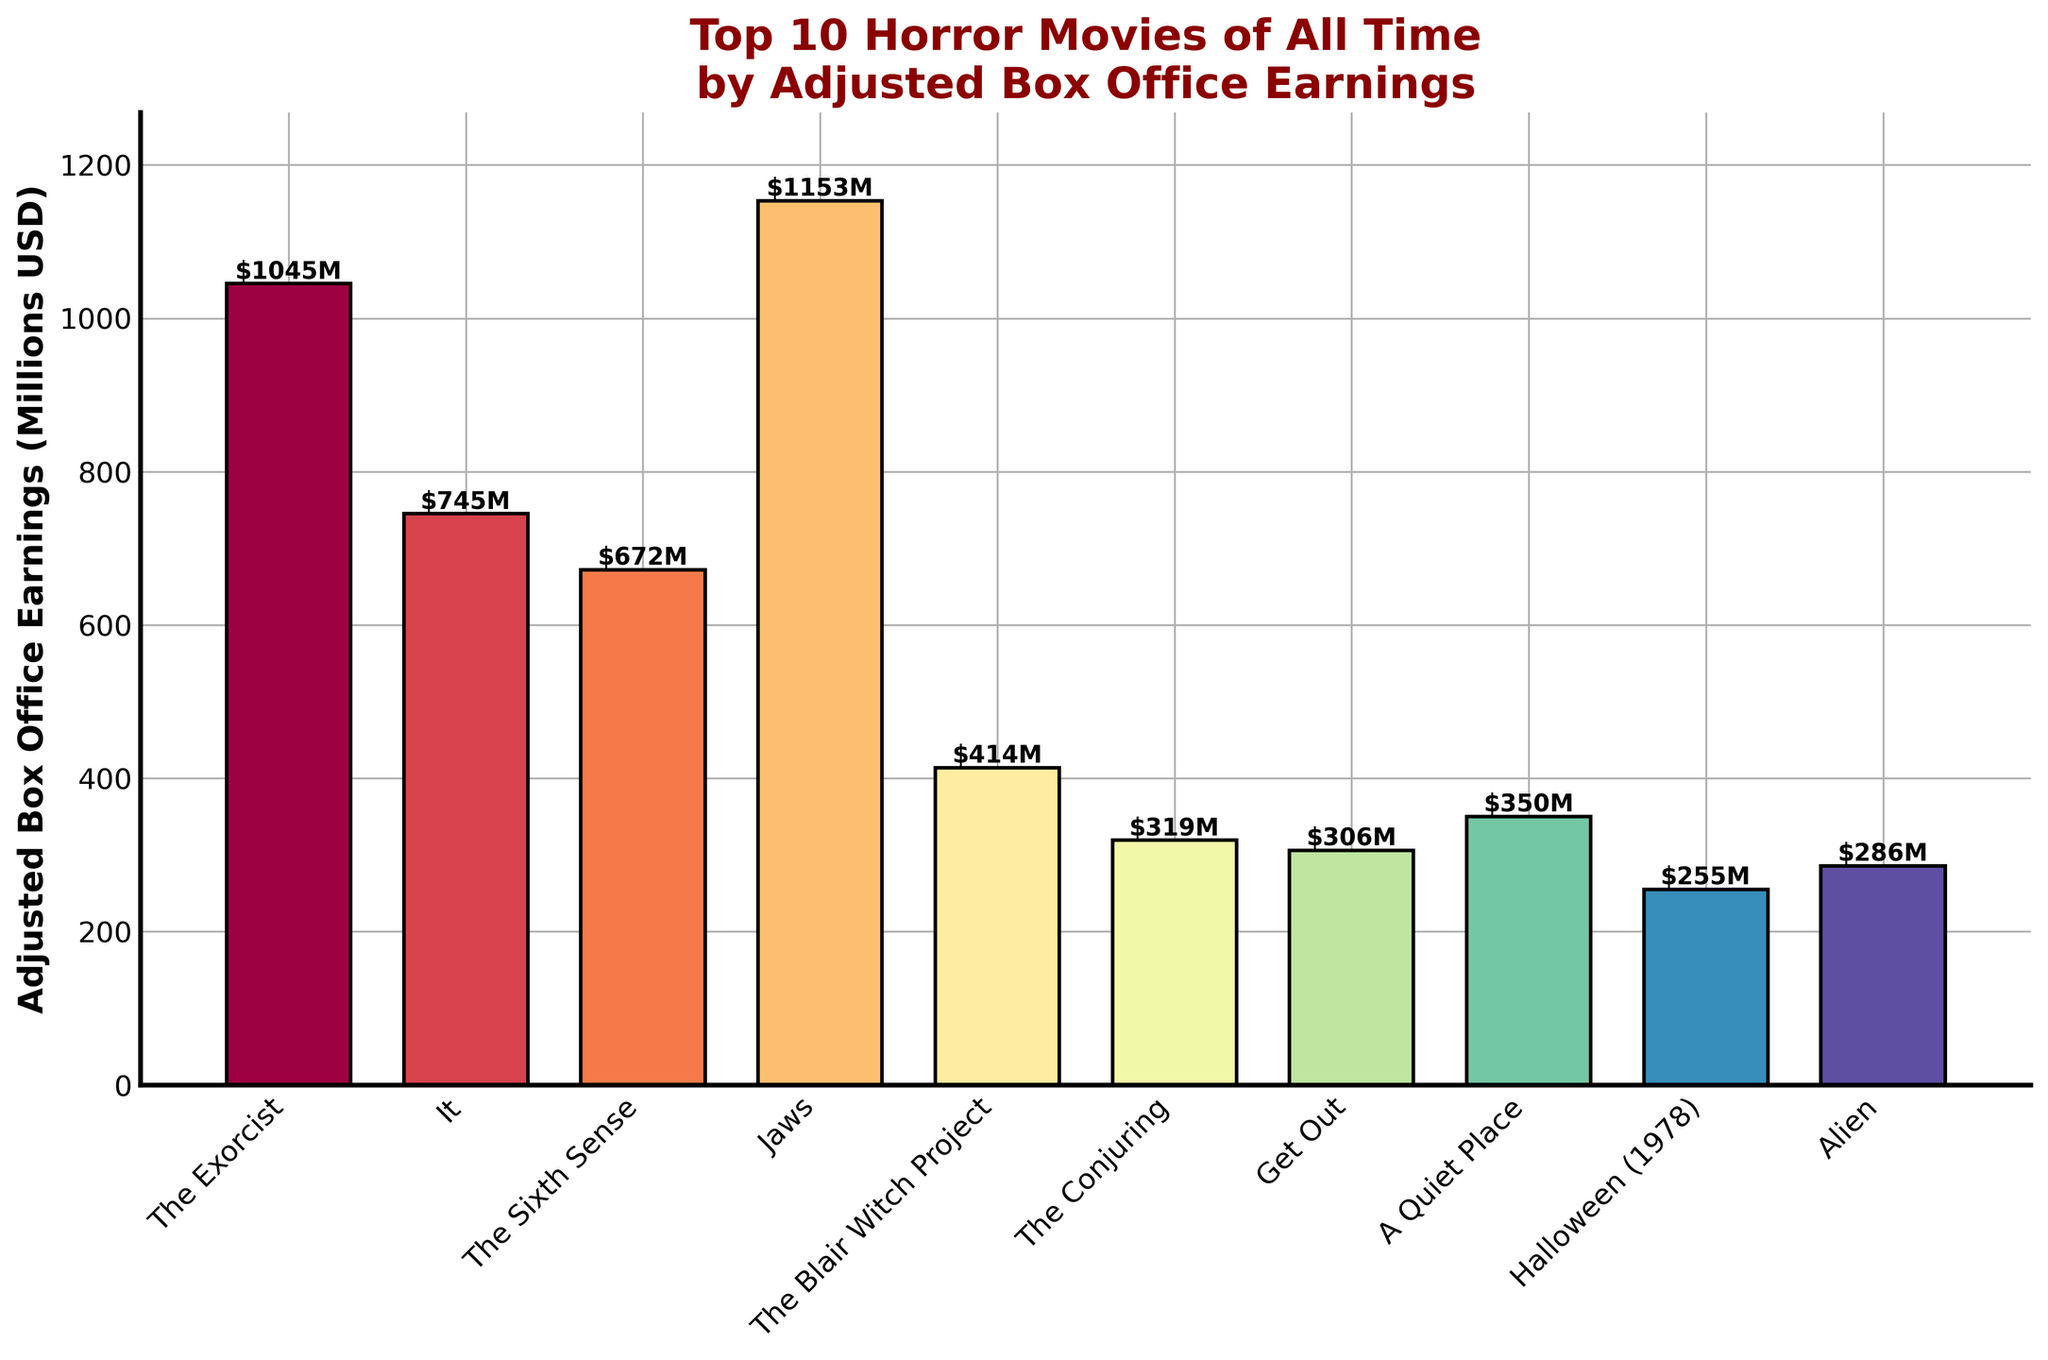Which movie has the highest adjusted box office earnings? The bar for "Jaws" is the tallest, indicating it has the highest earnings.
Answer: Jaws How much more did "The Exorcist" earn compared to "Alien"? "The Exorcist" earned $1045M, and "Alien" earned $286M. Subtracting the two earnings: 1045 - 286 = 759
Answer: 759 What is the combined adjusted box office earnings of "The Blair Witch Project" and "A Quiet Place"? "The Blair Witch Project" earned $414M and "A Quiet Place" earned $350M. Adding the two earnings: 414 + 350 = 764
Answer: 764 Which movie has the lowest adjusted box office earnings? The bar for "Halloween (1978)" is the shortest, indicating it has the lowest earnings.
Answer: Halloween (1978) How does the height of the bar for "The Conjuring" compare visually to that of "Get Out"? The bar for "The Conjuring" is slightly taller than the bar for "Get Out", suggesting "The Conjuring" has slightly higher earnings.
Answer: The Conjuring What is the median adjusted box office earnings amount among the top 10 horror movies? The earnings in ascending order are: 255, 286, 306, 319, 350, 414, 672, 745, 1045, 1153. The median is the average of the 5th and 6th values: (350 + 414) / 2 = 382
Answer: 382 How many movies earned over $700 million in adjusted box office earnings? The movies that earned over $700 million are "Jaws", "The Exorcist", and "It".
Answer: 3 Which movie earned the third-highest adjusted box office earnings? The third tallest bar belongs to "It", indicating it earned the third-highest amount.
Answer: It What is the difference in earnings between the highest and lowest earning movies? The highest earnings are by "Jaws" at $1153M, and the lowest by "Halloween (1978)" at $255M. Subtracting the two: 1153 - 255 = 898
Answer: 898 What is the average earning of the top 5 movies? The top 5 earnings are: 1153, 1045, 745, 672, and 414. Adding them and dividing by 5: (1153 + 1045 + 745 + 672 + 414) / 5 = 805.8
Answer: 805.8 